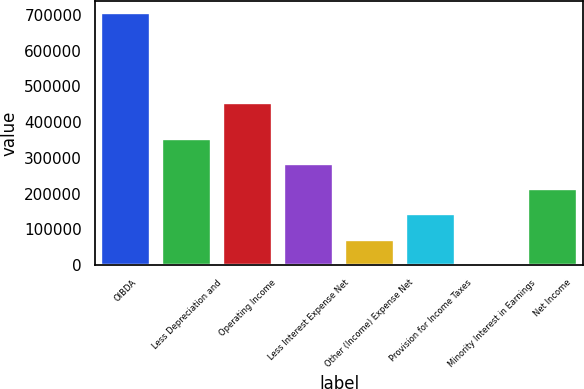Convert chart to OTSL. <chart><loc_0><loc_0><loc_500><loc_500><bar_chart><fcel>OIBDA<fcel>Less Depreciation and<fcel>Operating Income<fcel>Less Interest Expense Net<fcel>Other (Income) Expense Net<fcel>Provision for Income Taxes<fcel>Minority Interest in Earnings<fcel>Net Income<nl><fcel>704012<fcel>352466<fcel>454718<fcel>282157<fcel>71229.2<fcel>141538<fcel>920<fcel>211848<nl></chart> 